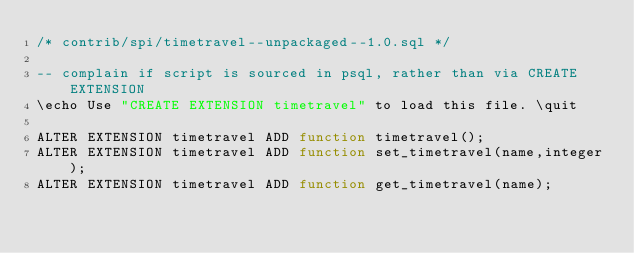Convert code to text. <code><loc_0><loc_0><loc_500><loc_500><_SQL_>/* contrib/spi/timetravel--unpackaged--1.0.sql */

-- complain if script is sourced in psql, rather than via CREATE EXTENSION
\echo Use "CREATE EXTENSION timetravel" to load this file. \quit

ALTER EXTENSION timetravel ADD function timetravel();
ALTER EXTENSION timetravel ADD function set_timetravel(name,integer);
ALTER EXTENSION timetravel ADD function get_timetravel(name);
</code> 